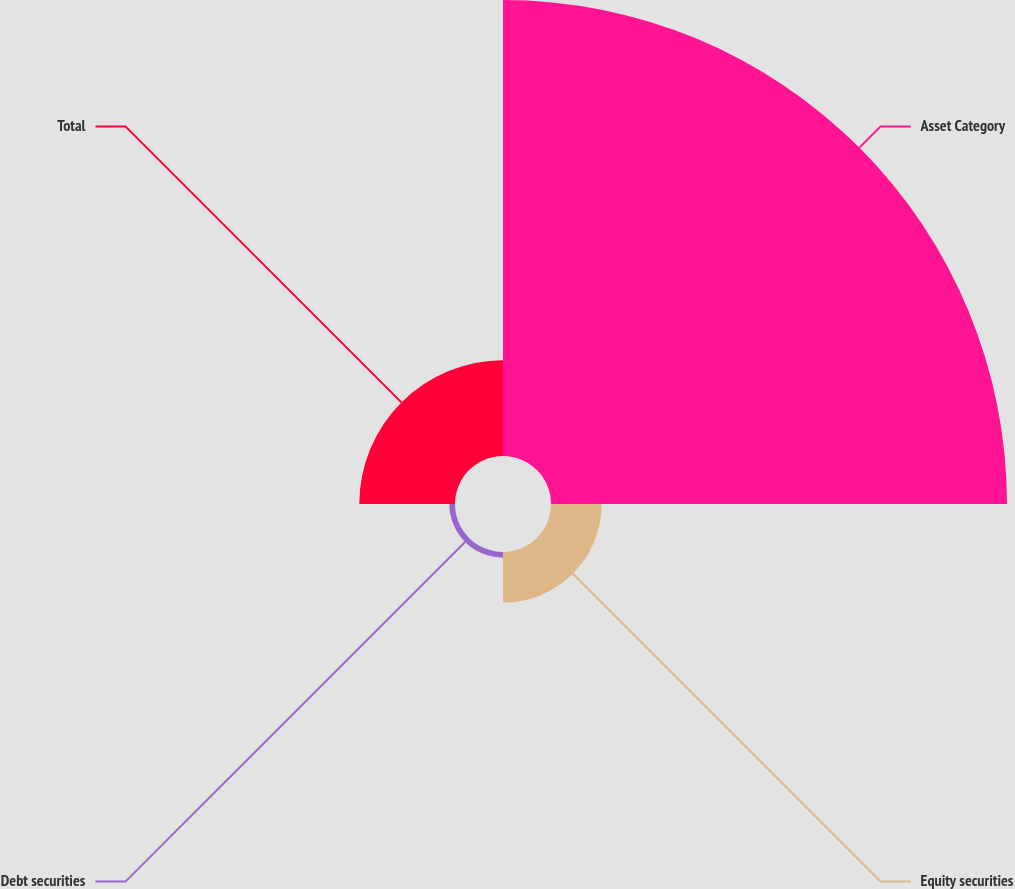<chart> <loc_0><loc_0><loc_500><loc_500><pie_chart><fcel>Asset Category<fcel>Equity securities<fcel>Debt securities<fcel>Total<nl><fcel>75.0%<fcel>8.33%<fcel>0.93%<fcel>15.74%<nl></chart> 